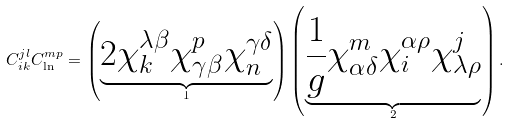<formula> <loc_0><loc_0><loc_500><loc_500>C _ { i k } ^ { j l } C _ { \ln } ^ { m p } = \left ( \underbrace { 2 \chi _ { k } ^ { \lambda \beta } \chi _ { \gamma \beta } ^ { p } \chi _ { n } ^ { \gamma \delta } } _ { 1 } \right ) \left ( \underbrace { \frac { 1 } { g } \chi _ { \alpha \delta } ^ { m } \chi _ { i } ^ { \alpha \rho } \chi _ { \lambda \rho } ^ { j } } _ { 2 } \right ) .</formula> 